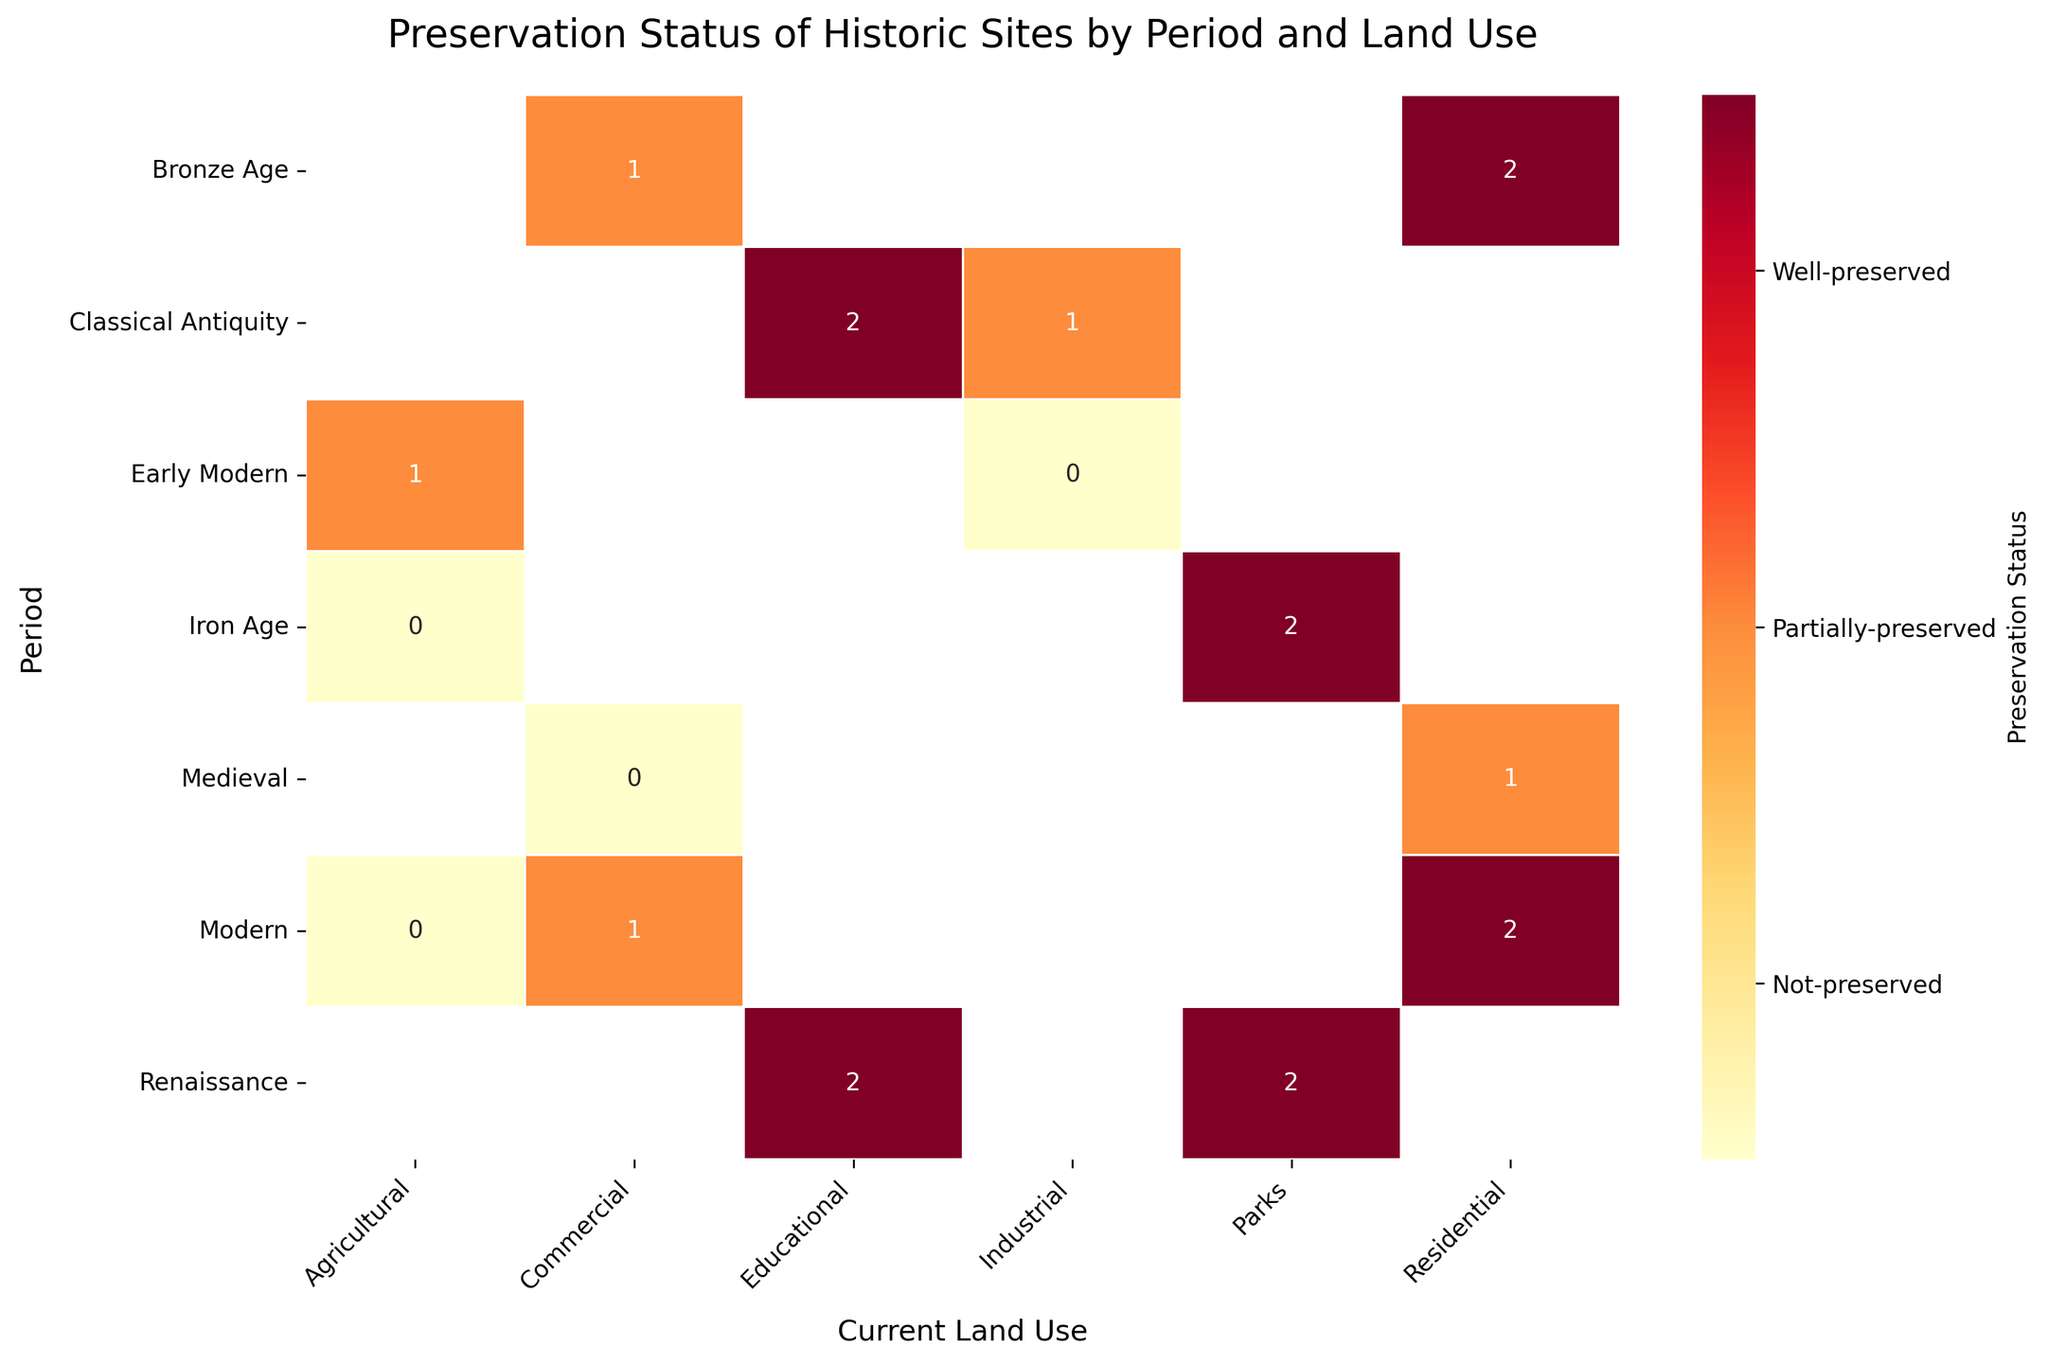What is the title of the heatmap? The title of a heatmap is usually displayed at the top of the figure. Observing the plot, we can identify the title text.
Answer: Preservation Status of Historic Sites by Period and Land Use Which period has the most "Well-preserved" status across all land uses? By examining each row corresponding to different periods, we can identify which period has the highest number of cells marked as "Well-preserved" (usually visible by color coding or annotations).
Answer: Modern How many different current land uses are shown in the heatmap? We can count the number of columns in the heatmap to determine how many different land uses are displayed.
Answer: 6 What is the preservation status of the Renaissance period for the Parks land use? Locate the row for the Renaissance period and the cell under the Parks column to find the preservation status.
Answer: Well-preserved Which current land use has the most "Not-preserved" status across all periods? By counting the number of cells marked as "Not-preserved" (usually denoted by a distinct color or annotation) in each column, we can determine which land use has the highest count.
Answer: Agricultural Is there any "Partially-preserved" status in the Educational land use? Locate the column for Educational land use and check if any of the cells in this column are marked as "Partially-preserved."
Answer: No What is the preservation status of the Industrial land use in the Early Modern period? Locate the Early Modern row and the cell under the Industrial column to find the preservation status.
Answer: Not-preserved Which period has the highest diversity in preservation status categories across different land uses? By examining each period (row) and identifying the number of unique preservation status categories (Well-preserved, Partially-preserved, Not-preserved), we can determine the period with the highest diversity.
Answer: Modern Which land use shows "Well-preserved" status consistently across more than one period? Identify the columns that contain "Well-preserved" status in more than one row.
Answer: Parks Is the preservation status more frequently "Partially-preserved" or "Not-preserved" for Commercial land use in all periods? Count the number of times "Partially-preserved" and "Not-preserved" statuses appear in the Commercial column and compare their frequencies.
Answer: Partially-preserved 